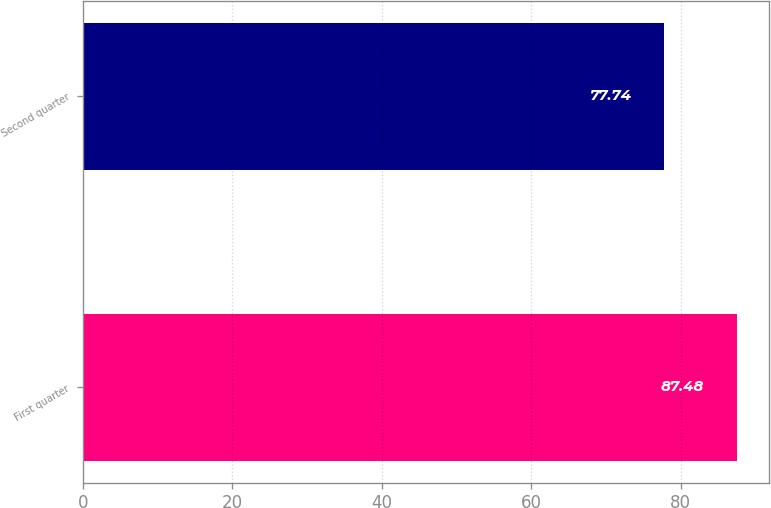<chart> <loc_0><loc_0><loc_500><loc_500><bar_chart><fcel>First quarter<fcel>Second quarter<nl><fcel>87.48<fcel>77.74<nl></chart> 